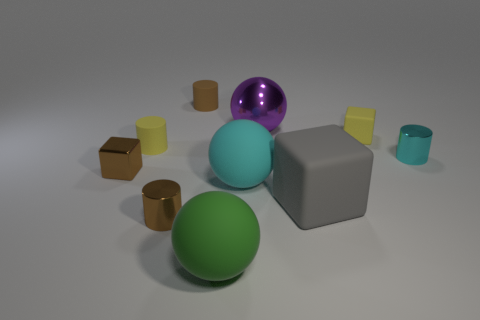Subtract all tiny cyan shiny cylinders. How many cylinders are left? 3 Add 8 rubber spheres. How many rubber spheres are left? 10 Add 6 balls. How many balls exist? 9 Subtract all green balls. How many balls are left? 2 Subtract 0 purple cylinders. How many objects are left? 10 Subtract all balls. How many objects are left? 7 Subtract 2 cylinders. How many cylinders are left? 2 Subtract all green balls. Subtract all cyan cylinders. How many balls are left? 2 Subtract all brown cylinders. How many blue balls are left? 0 Subtract all tiny blue metallic spheres. Subtract all big objects. How many objects are left? 6 